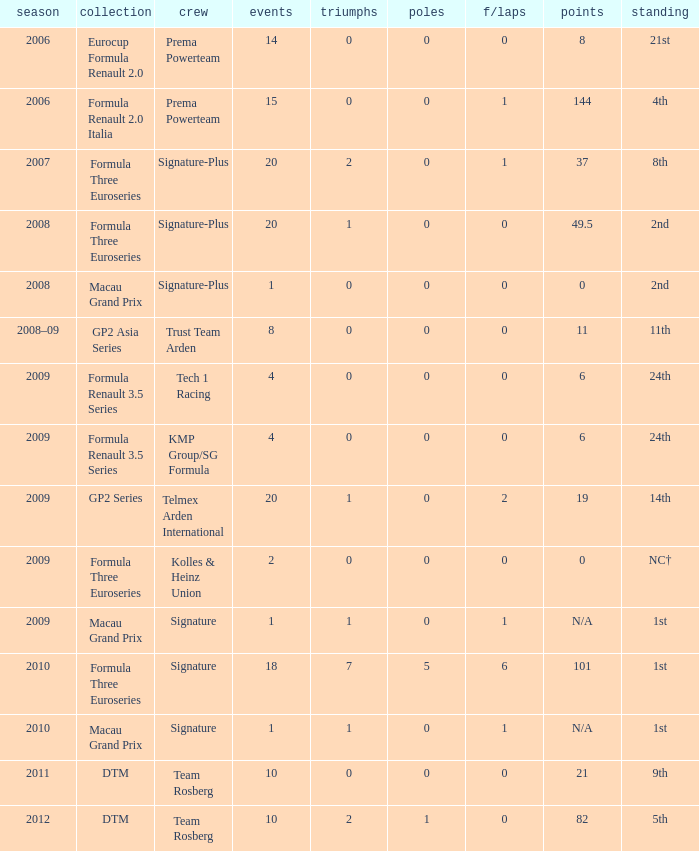How many poles are there in the Formula Three Euroseries in the 2008 season with more than 0 F/Laps? None. 